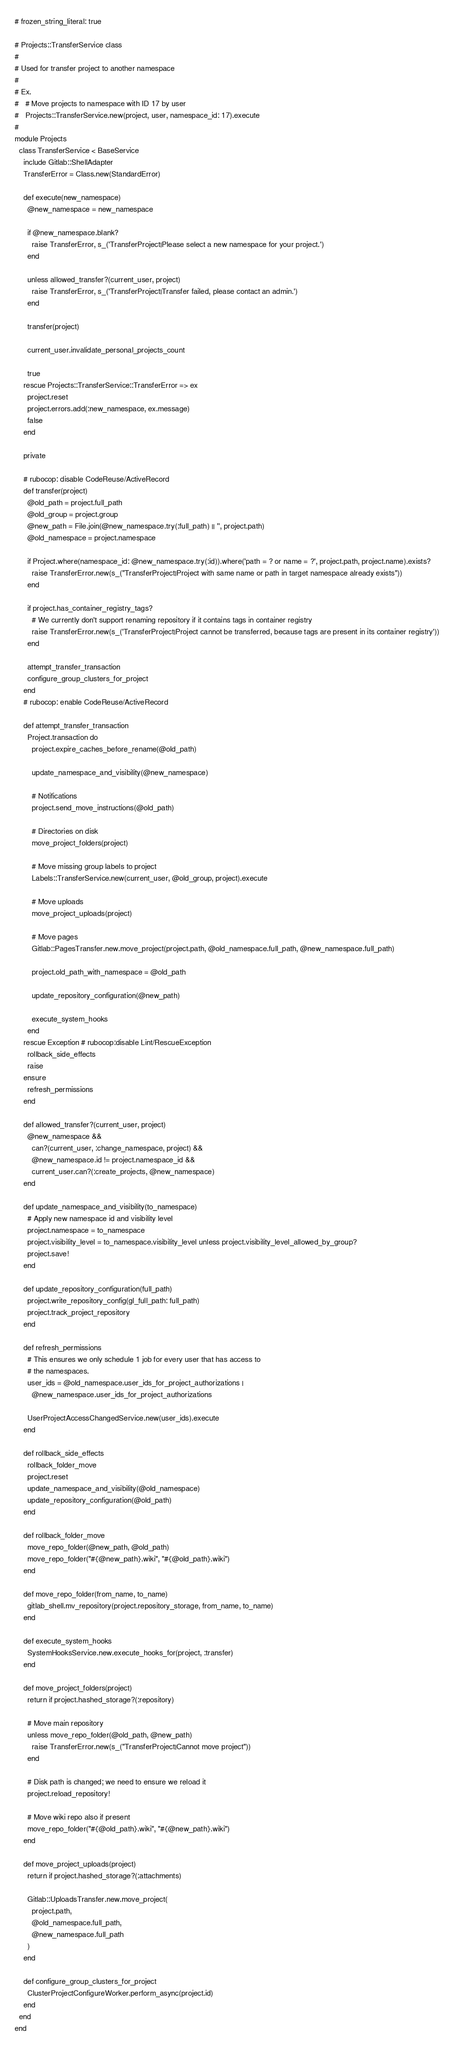<code> <loc_0><loc_0><loc_500><loc_500><_Ruby_># frozen_string_literal: true

# Projects::TransferService class
#
# Used for transfer project to another namespace
#
# Ex.
#   # Move projects to namespace with ID 17 by user
#   Projects::TransferService.new(project, user, namespace_id: 17).execute
#
module Projects
  class TransferService < BaseService
    include Gitlab::ShellAdapter
    TransferError = Class.new(StandardError)

    def execute(new_namespace)
      @new_namespace = new_namespace

      if @new_namespace.blank?
        raise TransferError, s_('TransferProject|Please select a new namespace for your project.')
      end

      unless allowed_transfer?(current_user, project)
        raise TransferError, s_('TransferProject|Transfer failed, please contact an admin.')
      end

      transfer(project)

      current_user.invalidate_personal_projects_count

      true
    rescue Projects::TransferService::TransferError => ex
      project.reset
      project.errors.add(:new_namespace, ex.message)
      false
    end

    private

    # rubocop: disable CodeReuse/ActiveRecord
    def transfer(project)
      @old_path = project.full_path
      @old_group = project.group
      @new_path = File.join(@new_namespace.try(:full_path) || '', project.path)
      @old_namespace = project.namespace

      if Project.where(namespace_id: @new_namespace.try(:id)).where('path = ? or name = ?', project.path, project.name).exists?
        raise TransferError.new(s_("TransferProject|Project with same name or path in target namespace already exists"))
      end

      if project.has_container_registry_tags?
        # We currently don't support renaming repository if it contains tags in container registry
        raise TransferError.new(s_('TransferProject|Project cannot be transferred, because tags are present in its container registry'))
      end

      attempt_transfer_transaction
      configure_group_clusters_for_project
    end
    # rubocop: enable CodeReuse/ActiveRecord

    def attempt_transfer_transaction
      Project.transaction do
        project.expire_caches_before_rename(@old_path)

        update_namespace_and_visibility(@new_namespace)

        # Notifications
        project.send_move_instructions(@old_path)

        # Directories on disk
        move_project_folders(project)

        # Move missing group labels to project
        Labels::TransferService.new(current_user, @old_group, project).execute

        # Move uploads
        move_project_uploads(project)

        # Move pages
        Gitlab::PagesTransfer.new.move_project(project.path, @old_namespace.full_path, @new_namespace.full_path)

        project.old_path_with_namespace = @old_path

        update_repository_configuration(@new_path)

        execute_system_hooks
      end
    rescue Exception # rubocop:disable Lint/RescueException
      rollback_side_effects
      raise
    ensure
      refresh_permissions
    end

    def allowed_transfer?(current_user, project)
      @new_namespace &&
        can?(current_user, :change_namespace, project) &&
        @new_namespace.id != project.namespace_id &&
        current_user.can?(:create_projects, @new_namespace)
    end

    def update_namespace_and_visibility(to_namespace)
      # Apply new namespace id and visibility level
      project.namespace = to_namespace
      project.visibility_level = to_namespace.visibility_level unless project.visibility_level_allowed_by_group?
      project.save!
    end

    def update_repository_configuration(full_path)
      project.write_repository_config(gl_full_path: full_path)
      project.track_project_repository
    end

    def refresh_permissions
      # This ensures we only schedule 1 job for every user that has access to
      # the namespaces.
      user_ids = @old_namespace.user_ids_for_project_authorizations |
        @new_namespace.user_ids_for_project_authorizations

      UserProjectAccessChangedService.new(user_ids).execute
    end

    def rollback_side_effects
      rollback_folder_move
      project.reset
      update_namespace_and_visibility(@old_namespace)
      update_repository_configuration(@old_path)
    end

    def rollback_folder_move
      move_repo_folder(@new_path, @old_path)
      move_repo_folder("#{@new_path}.wiki", "#{@old_path}.wiki")
    end

    def move_repo_folder(from_name, to_name)
      gitlab_shell.mv_repository(project.repository_storage, from_name, to_name)
    end

    def execute_system_hooks
      SystemHooksService.new.execute_hooks_for(project, :transfer)
    end

    def move_project_folders(project)
      return if project.hashed_storage?(:repository)

      # Move main repository
      unless move_repo_folder(@old_path, @new_path)
        raise TransferError.new(s_("TransferProject|Cannot move project"))
      end

      # Disk path is changed; we need to ensure we reload it
      project.reload_repository!

      # Move wiki repo also if present
      move_repo_folder("#{@old_path}.wiki", "#{@new_path}.wiki")
    end

    def move_project_uploads(project)
      return if project.hashed_storage?(:attachments)

      Gitlab::UploadsTransfer.new.move_project(
        project.path,
        @old_namespace.full_path,
        @new_namespace.full_path
      )
    end

    def configure_group_clusters_for_project
      ClusterProjectConfigureWorker.perform_async(project.id)
    end
  end
end
</code> 